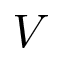Convert formula to latex. <formula><loc_0><loc_0><loc_500><loc_500>V</formula> 